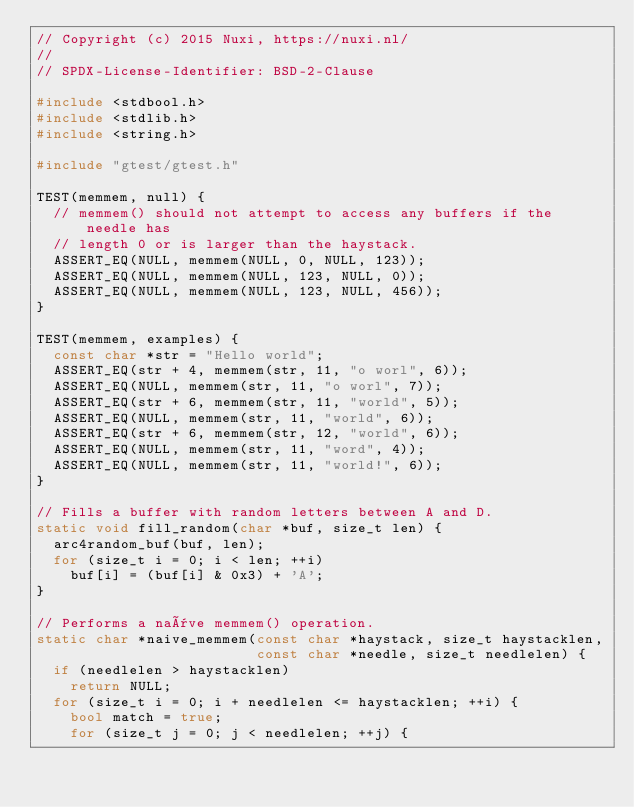Convert code to text. <code><loc_0><loc_0><loc_500><loc_500><_C++_>// Copyright (c) 2015 Nuxi, https://nuxi.nl/
//
// SPDX-License-Identifier: BSD-2-Clause

#include <stdbool.h>
#include <stdlib.h>
#include <string.h>

#include "gtest/gtest.h"

TEST(memmem, null) {
  // memmem() should not attempt to access any buffers if the needle has
  // length 0 or is larger than the haystack.
  ASSERT_EQ(NULL, memmem(NULL, 0, NULL, 123));
  ASSERT_EQ(NULL, memmem(NULL, 123, NULL, 0));
  ASSERT_EQ(NULL, memmem(NULL, 123, NULL, 456));
}

TEST(memmem, examples) {
  const char *str = "Hello world";
  ASSERT_EQ(str + 4, memmem(str, 11, "o worl", 6));
  ASSERT_EQ(NULL, memmem(str, 11, "o worl", 7));
  ASSERT_EQ(str + 6, memmem(str, 11, "world", 5));
  ASSERT_EQ(NULL, memmem(str, 11, "world", 6));
  ASSERT_EQ(str + 6, memmem(str, 12, "world", 6));
  ASSERT_EQ(NULL, memmem(str, 11, "word", 4));
  ASSERT_EQ(NULL, memmem(str, 11, "world!", 6));
}

// Fills a buffer with random letters between A and D.
static void fill_random(char *buf, size_t len) {
  arc4random_buf(buf, len);
  for (size_t i = 0; i < len; ++i)
    buf[i] = (buf[i] & 0x3) + 'A';
}

// Performs a naïve memmem() operation.
static char *naive_memmem(const char *haystack, size_t haystacklen,
                          const char *needle, size_t needlelen) {
  if (needlelen > haystacklen)
    return NULL;
  for (size_t i = 0; i + needlelen <= haystacklen; ++i) {
    bool match = true;
    for (size_t j = 0; j < needlelen; ++j) {</code> 